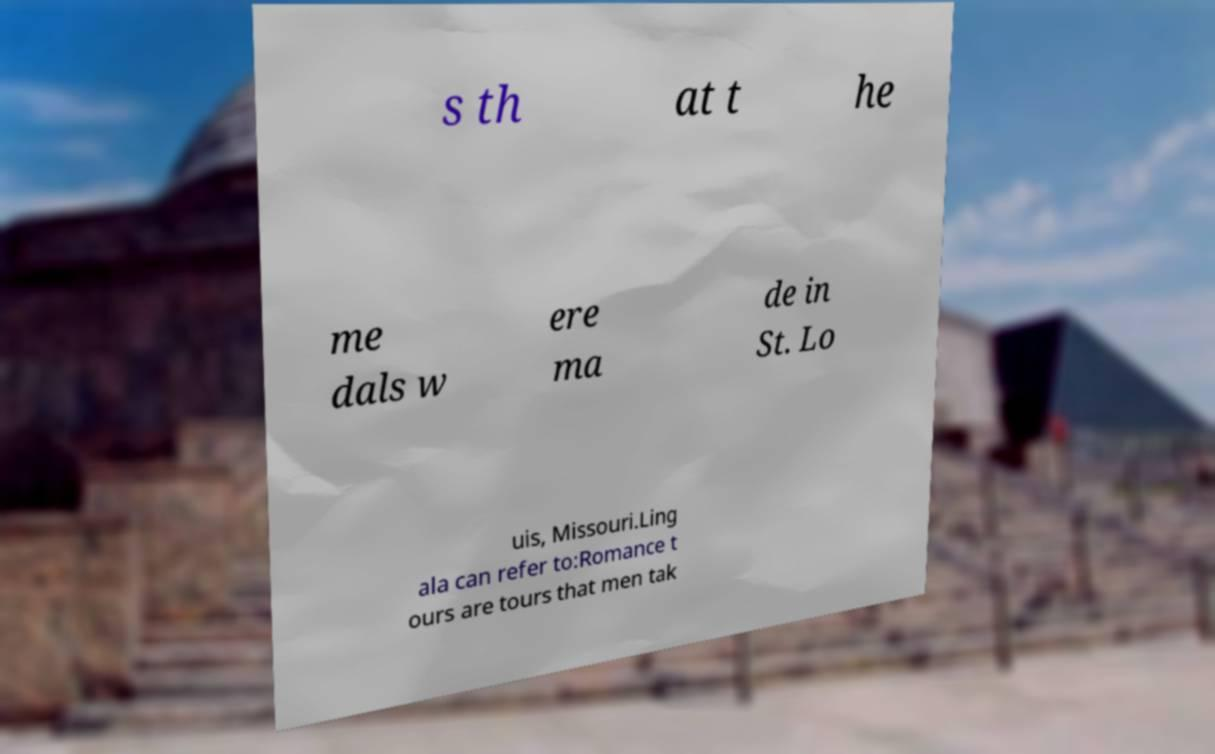What messages or text are displayed in this image? I need them in a readable, typed format. s th at t he me dals w ere ma de in St. Lo uis, Missouri.Ling ala can refer to:Romance t ours are tours that men tak 